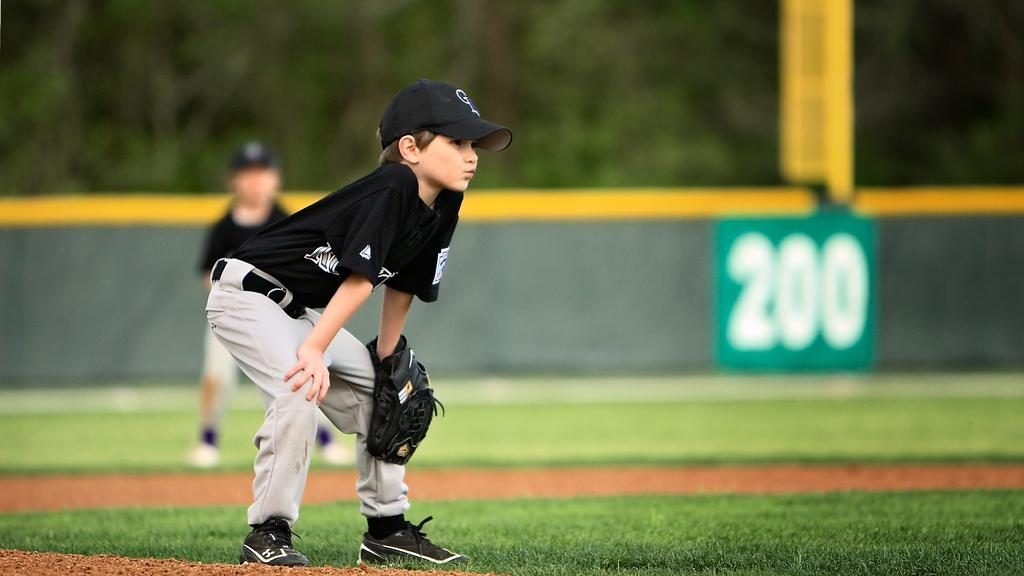How many kids are in the image? There are two kids in the image. What activity are the kids engaged in? The kids are playing baseball. Can you describe any other objects in the image? There is a board with a number and a pole in the image. What type of surface is visible in the image? Grass is present in the image. How would you describe the background of the image? The background of the image is blurred. What type of cracker is being used as a bat in the image? There is no cracker being used as a bat in the image; the kids are playing baseball with a baseball bat. Is there a party happening in the image? There is no indication of a party in the image; it shows two kids playing baseball. 